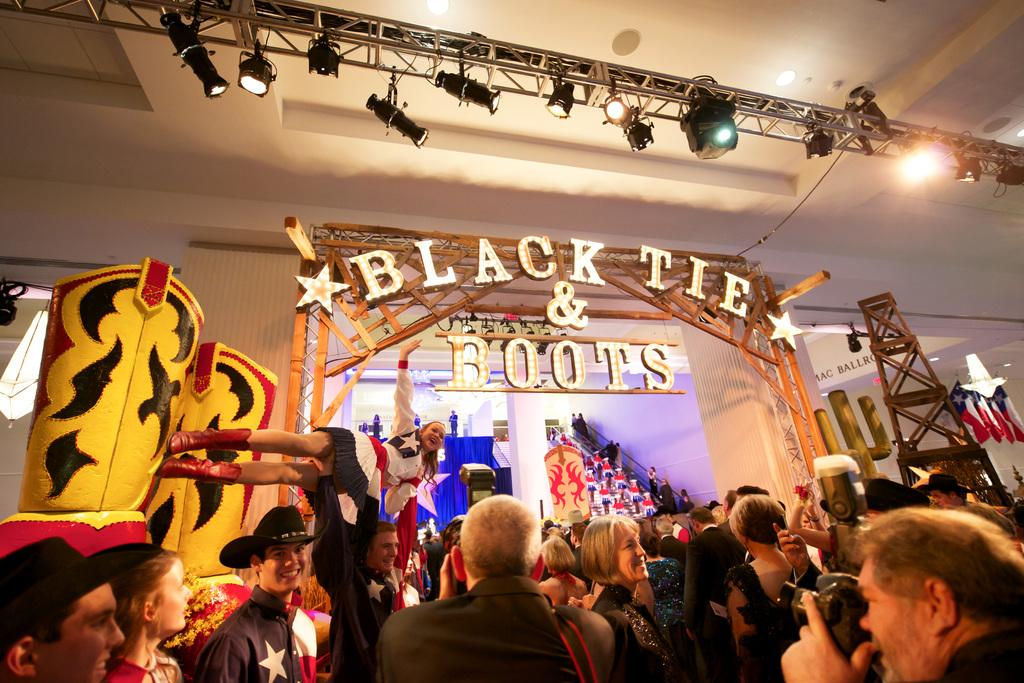How many people can be seen in the image? There are people in the image, but the exact number is not specified. What type of lighting is present in the image? There are lights in the image, but their specific type is not mentioned. What part of the room is visible in the image? The ceiling is visible in the image, along with other parts of the room. What architectural features are present in the image? Pillars are present in the image, as well as a wall. What additional objects can be seen in the image? Flags and a board are visible in the image, along with other objects. What type of footwear is the person wearing in the image? There is no information about footwear in the image, as the focus is on the people, lights, ceiling, pillars, wall, flags, and board. 